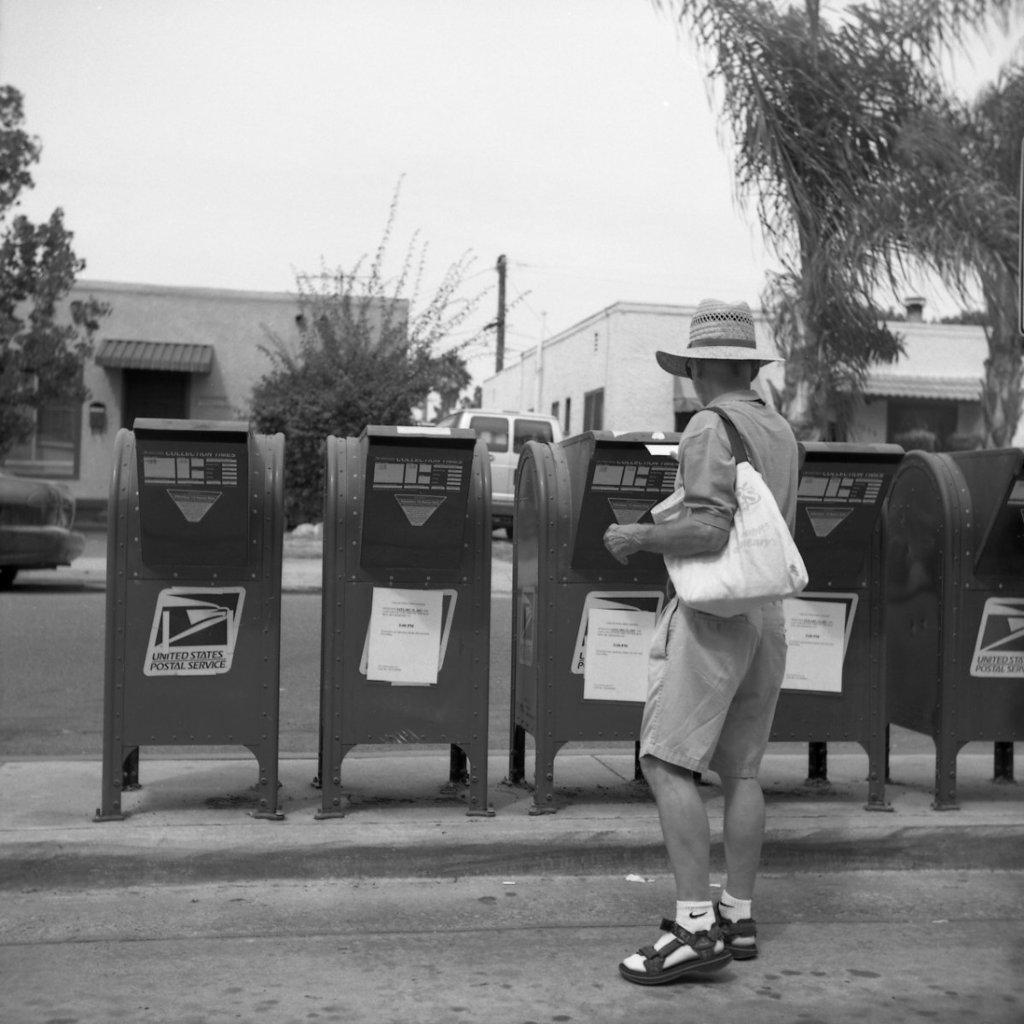<image>
Describe the image concisely. Man standing in front of a mailbox which says United States Postal Service. 